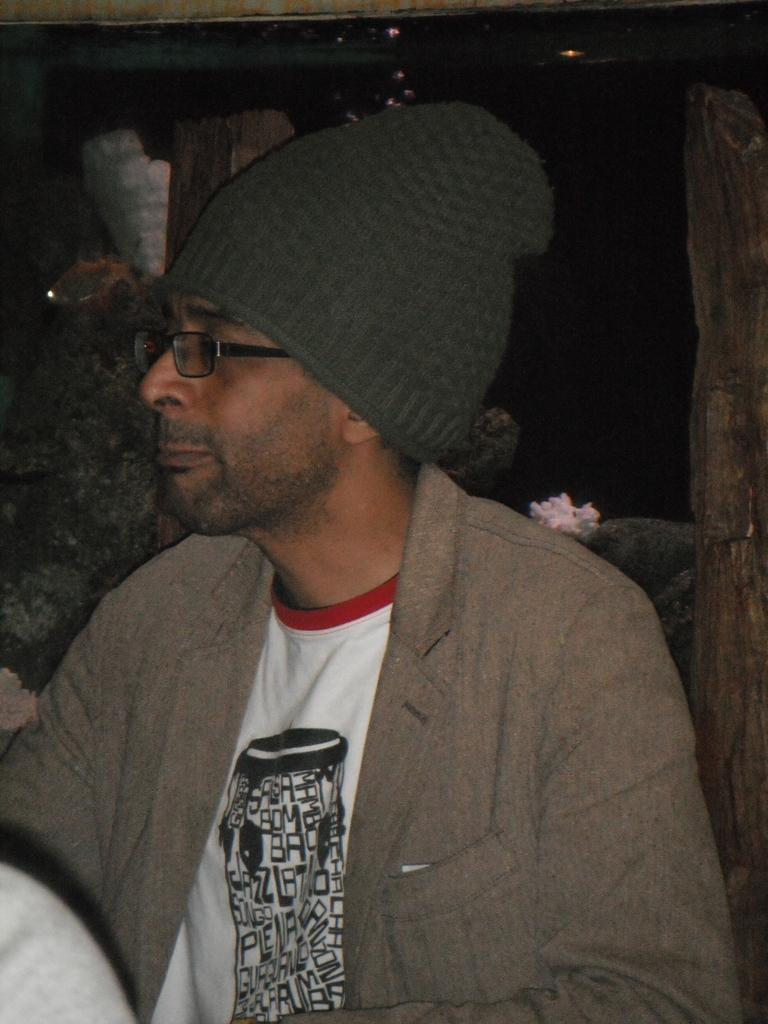Who is present in the image? There is a person in the image. What accessories is the person wearing? The person is wearing spectacles and a cap. What can be seen in the background of the image? There is a wall and wooden poles in the background of the image. What type of nail is being hammered into the wall in the image? There is no nail being hammered into the wall in the image. What type of sweater is the person wearing in the image? The person is not wearing a sweater in the image; they are wearing a cap and spectacles. 